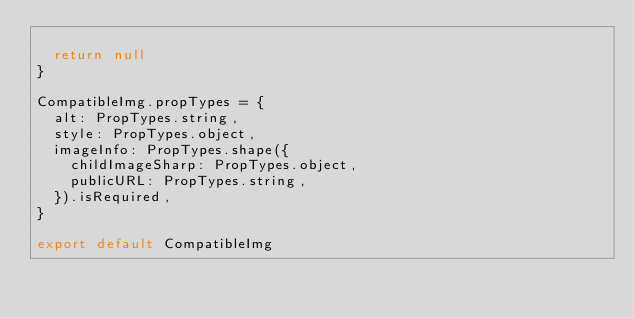Convert code to text. <code><loc_0><loc_0><loc_500><loc_500><_JavaScript_>
  return null
}

CompatibleImg.propTypes = {
  alt: PropTypes.string,
  style: PropTypes.object,
  imageInfo: PropTypes.shape({
    childImageSharp: PropTypes.object,
    publicURL: PropTypes.string,
  }).isRequired,
}

export default CompatibleImg
</code> 